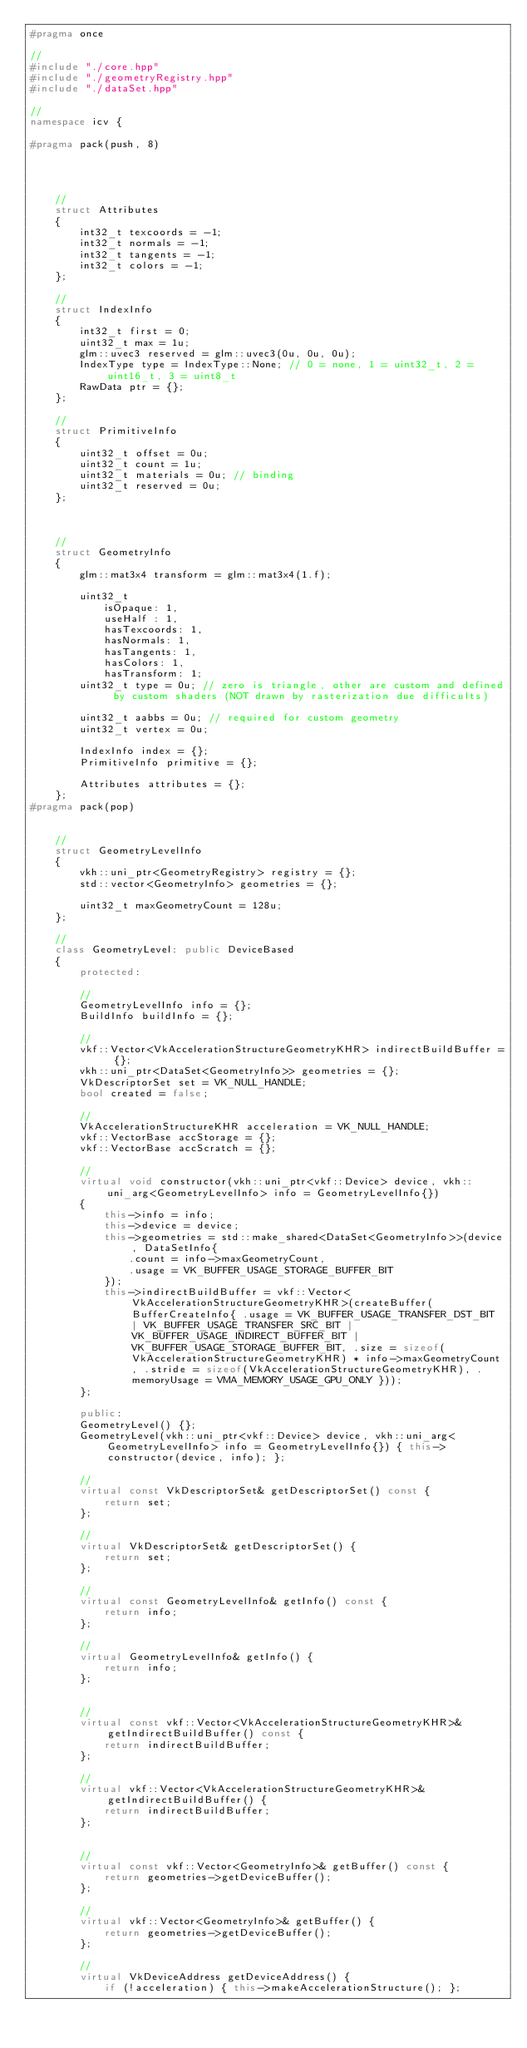<code> <loc_0><loc_0><loc_500><loc_500><_C++_>#pragma once

// 
#include "./core.hpp"
#include "./geometryRegistry.hpp"
#include "./dataSet.hpp"

// 
namespace icv {

#pragma pack(push, 8)

    


    // 
    struct Attributes 
    {
        int32_t texcoords = -1;
        int32_t normals = -1;
        int32_t tangents = -1;
        int32_t colors = -1;
    };

    // 
    struct IndexInfo 
    {
        int32_t first = 0;
        uint32_t max = 1u;
        glm::uvec3 reserved = glm::uvec3(0u, 0u, 0u);
        IndexType type = IndexType::None; // 0 = none, 1 = uint32_t, 2 = uint16_t, 3 = uint8_t
        RawData ptr = {};
    };

    //
    struct PrimitiveInfo 
    {
        uint32_t offset = 0u;
        uint32_t count = 1u;
        uint32_t materials = 0u; // binding
        uint32_t reserved = 0u;
    };

    

    // 
    struct GeometryInfo 
    {
        glm::mat3x4 transform = glm::mat3x4(1.f);

        uint32_t 
            isOpaque: 1,
            useHalf : 1,
            hasTexcoords: 1, 
            hasNormals: 1,
            hasTangents: 1,
            hasColors: 1,
            hasTransform: 1;
        uint32_t type = 0u; // zero is triangle, other are custom and defined by custom shaders (NOT drawn by rasterization due difficults)

        uint32_t aabbs = 0u; // required for custom geometry
        uint32_t vertex = 0u;

        IndexInfo index = {};
        PrimitiveInfo primitive = {};

        Attributes attributes = {};
    };
#pragma pack(pop)


    // 
    struct GeometryLevelInfo 
    {
        vkh::uni_ptr<GeometryRegistry> registry = {};
        std::vector<GeometryInfo> geometries = {};

        uint32_t maxGeometryCount = 128u;
    };

    // 
    class GeometryLevel: public DeviceBased 
    {
        protected: 

        // 
        GeometryLevelInfo info = {};
        BuildInfo buildInfo = {};

        // 
        vkf::Vector<VkAccelerationStructureGeometryKHR> indirectBuildBuffer = {};
        vkh::uni_ptr<DataSet<GeometryInfo>> geometries = {};
        VkDescriptorSet set = VK_NULL_HANDLE;
        bool created = false;

        // 
        VkAccelerationStructureKHR acceleration = VK_NULL_HANDLE;
        vkf::VectorBase accStorage = {};
        vkf::VectorBase accScratch = {};

        //
        virtual void constructor(vkh::uni_ptr<vkf::Device> device, vkh::uni_arg<GeometryLevelInfo> info = GeometryLevelInfo{}) 
        {
            this->info = info;
            this->device = device;
            this->geometries = std::make_shared<DataSet<GeometryInfo>>(device, DataSetInfo{
                .count = info->maxGeometryCount,
                .usage = VK_BUFFER_USAGE_STORAGE_BUFFER_BIT
            });
            this->indirectBuildBuffer = vkf::Vector<VkAccelerationStructureGeometryKHR>(createBuffer(BufferCreateInfo{ .usage = VK_BUFFER_USAGE_TRANSFER_DST_BIT | VK_BUFFER_USAGE_TRANSFER_SRC_BIT | VK_BUFFER_USAGE_INDIRECT_BUFFER_BIT | VK_BUFFER_USAGE_STORAGE_BUFFER_BIT, .size = sizeof(VkAccelerationStructureGeometryKHR) * info->maxGeometryCount, .stride = sizeof(VkAccelerationStructureGeometryKHR), .memoryUsage = VMA_MEMORY_USAGE_GPU_ONLY }));
        };

        public: 
        GeometryLevel() {};
        GeometryLevel(vkh::uni_ptr<vkf::Device> device, vkh::uni_arg<GeometryLevelInfo> info = GeometryLevelInfo{}) { this->constructor(device, info); };

        //
        virtual const VkDescriptorSet& getDescriptorSet() const {
            return set;
        };

        //
        virtual VkDescriptorSet& getDescriptorSet() {
            return set;
        };

        //
        virtual const GeometryLevelInfo& getInfo() const {
            return info;
        };

        //
        virtual GeometryLevelInfo& getInfo() {
            return info;
        };


        //
        virtual const vkf::Vector<VkAccelerationStructureGeometryKHR>& getIndirectBuildBuffer() const {
            return indirectBuildBuffer;
        };

        //
        virtual vkf::Vector<VkAccelerationStructureGeometryKHR>& getIndirectBuildBuffer() {
            return indirectBuildBuffer;
        };


        //
        virtual const vkf::Vector<GeometryInfo>& getBuffer() const {
            return geometries->getDeviceBuffer();
        };

        //
        virtual vkf::Vector<GeometryInfo>& getBuffer() {
            return geometries->getDeviceBuffer();
        };

        //
        virtual VkDeviceAddress getDeviceAddress() {
            if (!acceleration) { this->makeAccelerationStructure(); };</code> 